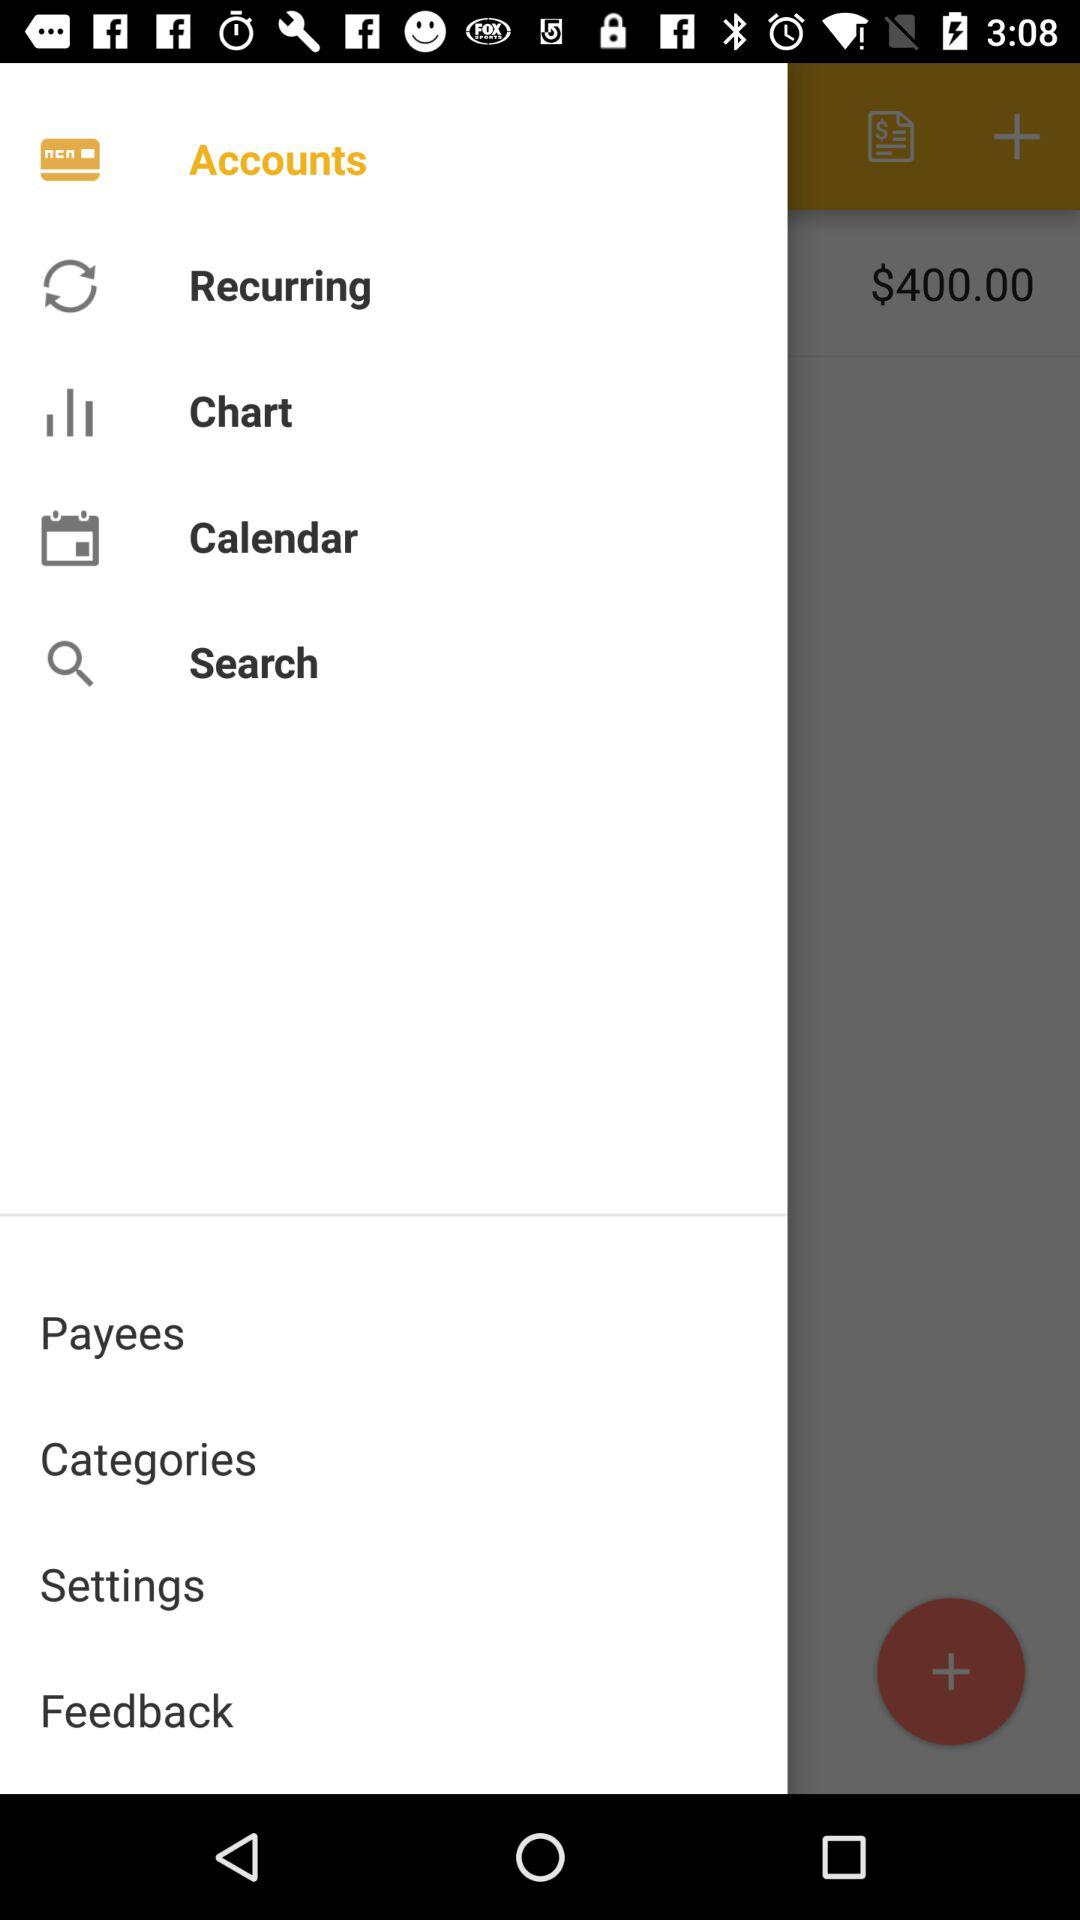What features does this banking app offer? The banking app shown in the image offers a range of features including 'Accounts' to view balances and transactions, 'Recurring' likely for managing regular transactions, 'Chart' for visualizing financial data, 'Calendar' to oversee scheduled transactions, 'Search' for finding specific transactions, 'Payees' for managing the entities you pay, 'Categories' to organize your expenses, and 'Settings' to personalize the app experience. Additionally, there's a 'Feedback' section where you can provide your thoughts on the app's functionality. 